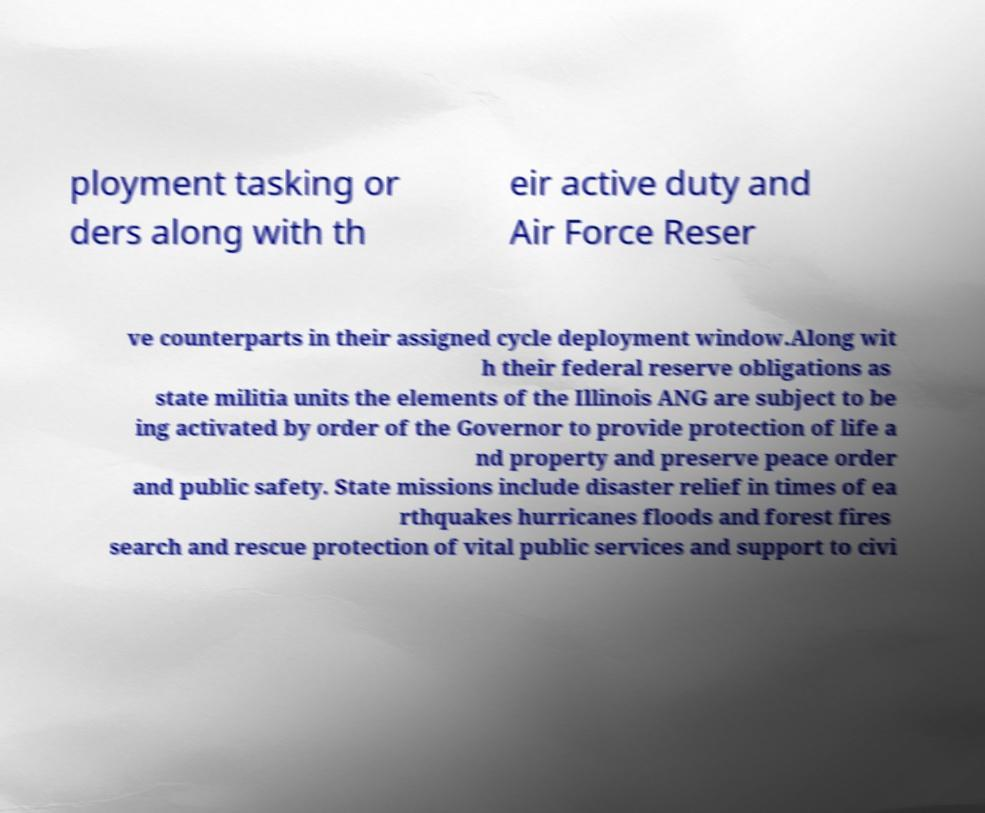Can you accurately transcribe the text from the provided image for me? ployment tasking or ders along with th eir active duty and Air Force Reser ve counterparts in their assigned cycle deployment window.Along wit h their federal reserve obligations as state militia units the elements of the Illinois ANG are subject to be ing activated by order of the Governor to provide protection of life a nd property and preserve peace order and public safety. State missions include disaster relief in times of ea rthquakes hurricanes floods and forest fires search and rescue protection of vital public services and support to civi 